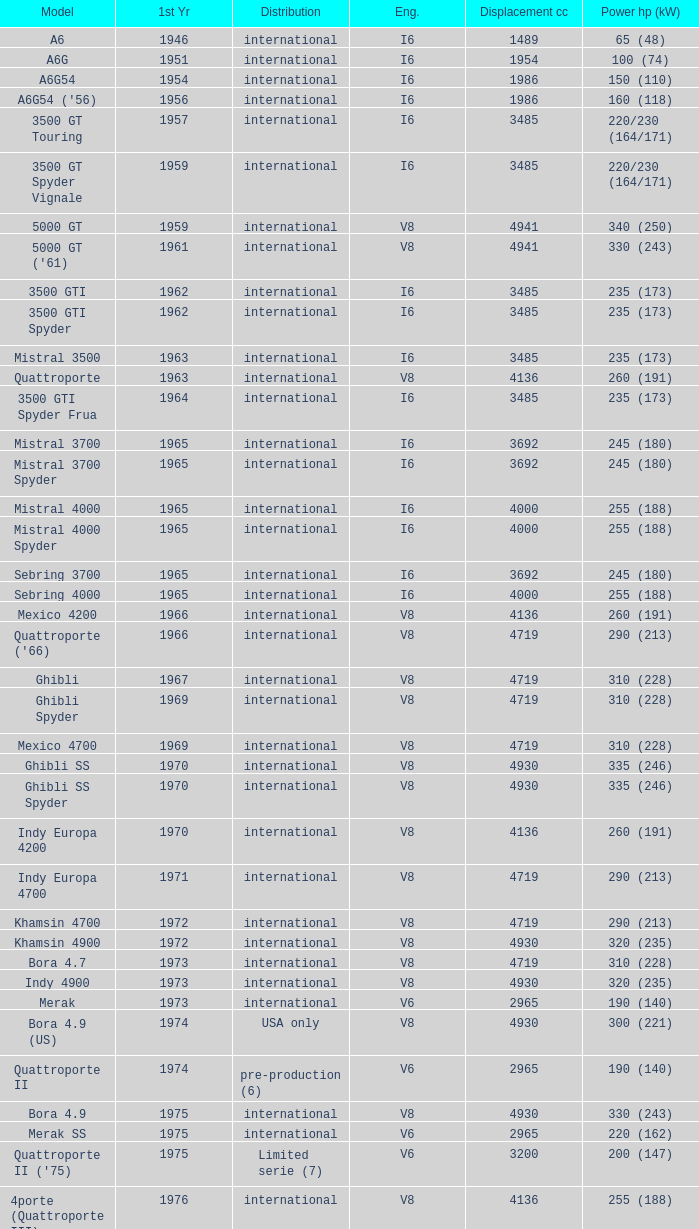What is Power HP (kW), when First Year is greater than 1965, when Distribution is "International", when Engine is V6 Biturbo, and when Model is "425"? 200 (147). 